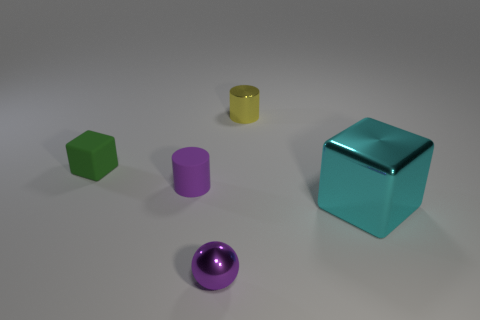What materials do the objects in the image seem to be made of? The objects in the image have a glossy finish, suggesting they could be made of a hard, reflective material, such as plastic or polished metal. 